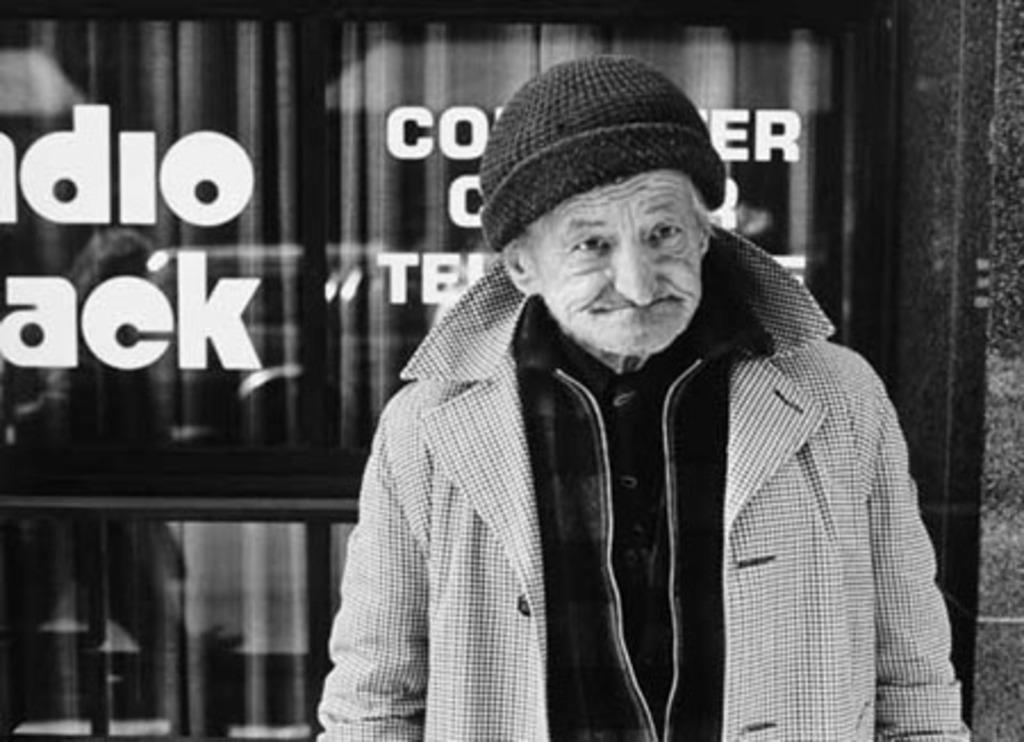Can you describe this image briefly? In this image I can see a person standing a wearing jacket and a cap, background I can see a glass wall and something written on it and the image is in black and white. 